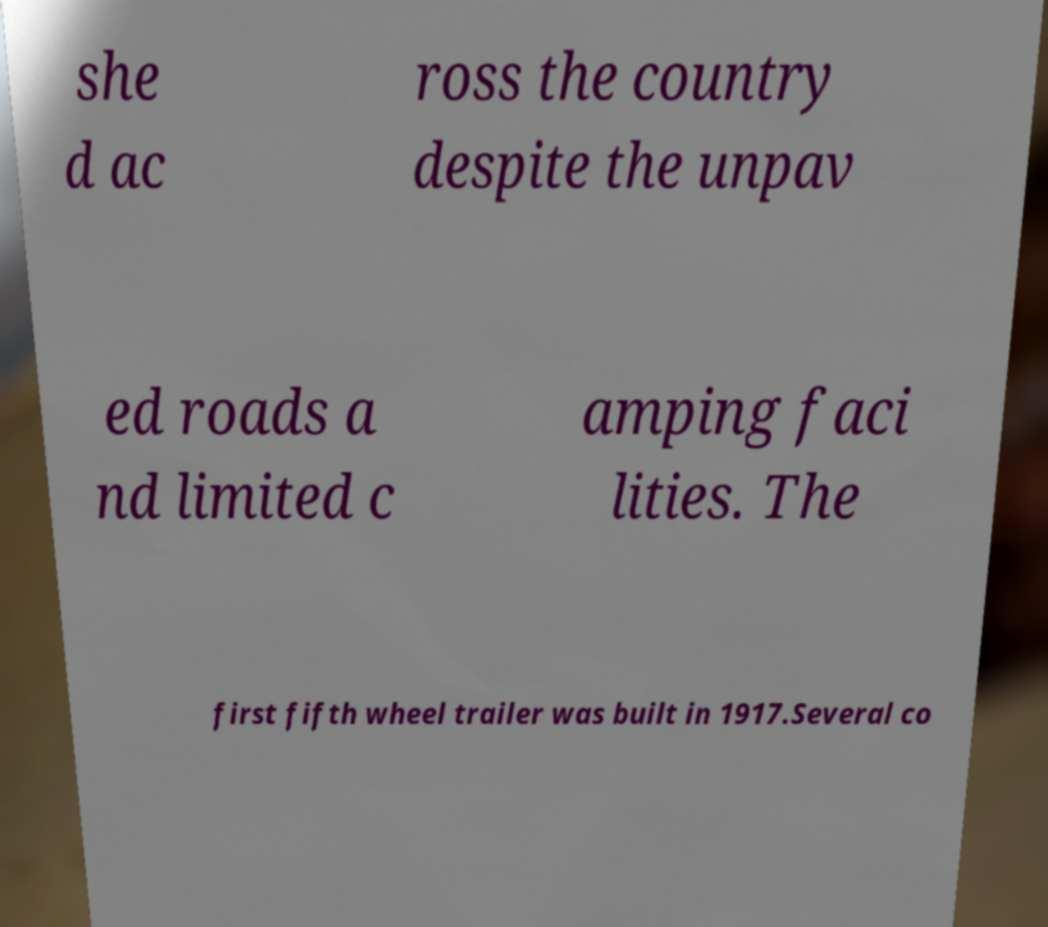For documentation purposes, I need the text within this image transcribed. Could you provide that? she d ac ross the country despite the unpav ed roads a nd limited c amping faci lities. The first fifth wheel trailer was built in 1917.Several co 